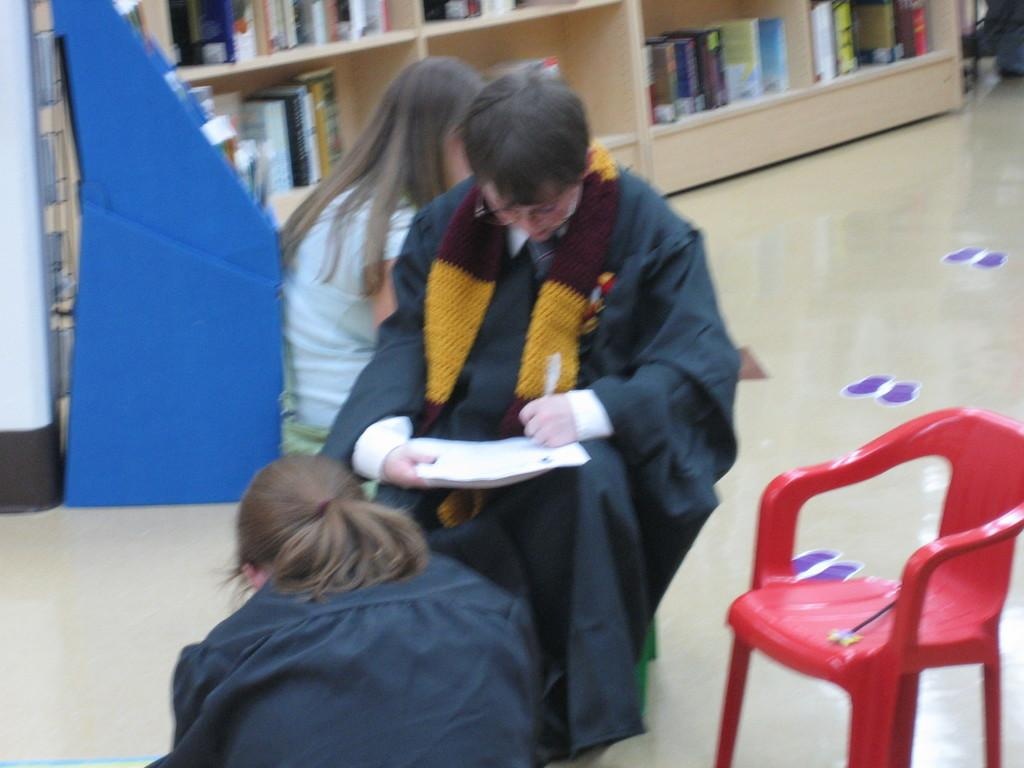How many people are sitting in the image? There are three persons sitting in the image. What type of furniture is present in the image? There is a chair in the image. What can be seen on the wooden shelf? There are books on the wooden shelf in the image. What is the surface on which the chair and shelf are placed? There is a floor in the image. What type of test is being conducted in the image? There is no test being conducted in the image; it features three persons sitting, a chair, a wooden shelf with books, and a floor. What religious symbols can be seen in the image? There are no religious symbols present in the image. 